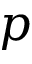Convert formula to latex. <formula><loc_0><loc_0><loc_500><loc_500>p</formula> 